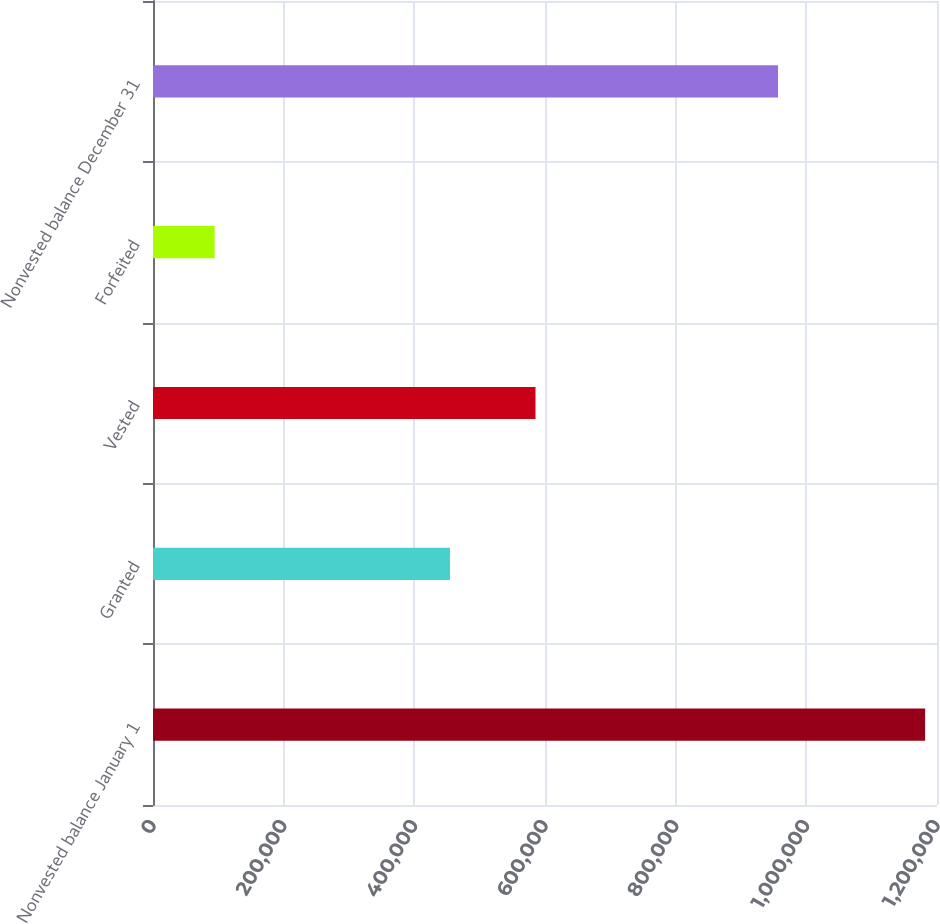Convert chart. <chart><loc_0><loc_0><loc_500><loc_500><bar_chart><fcel>Nonvested balance January 1<fcel>Granted<fcel>Vested<fcel>Forfeited<fcel>Nonvested balance December 31<nl><fcel>1.18181e+06<fcel>454663<fcel>585478<fcel>94300<fcel>956697<nl></chart> 